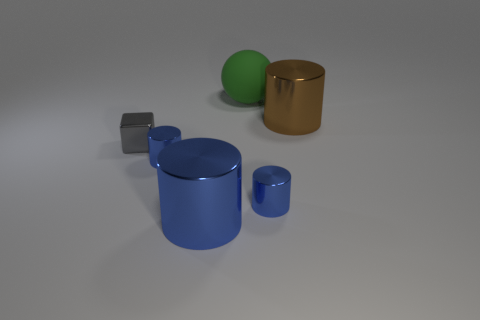Are there any other things that are the same material as the large green sphere?
Keep it short and to the point. No. There is a big metallic object that is behind the cylinder that is left of the big metallic cylinder on the left side of the brown thing; what is its color?
Make the answer very short. Brown. What color is the other large metallic thing that is the same shape as the brown metallic thing?
Your answer should be very brief. Blue. Is there any other thing of the same color as the tiny metallic cube?
Provide a short and direct response. No. How many other objects are there of the same material as the brown object?
Give a very brief answer. 4. How big is the gray metal block?
Offer a very short reply. Small. Is there a gray metal thing that has the same shape as the large rubber object?
Make the answer very short. No. How many things are either big purple rubber things or metallic cylinders in front of the shiny cube?
Provide a short and direct response. 3. There is a big object in front of the big brown metallic thing; what is its color?
Your answer should be very brief. Blue. There is a gray shiny thing in front of the big green rubber object; does it have the same size as the shiny cylinder behind the gray thing?
Give a very brief answer. No. 